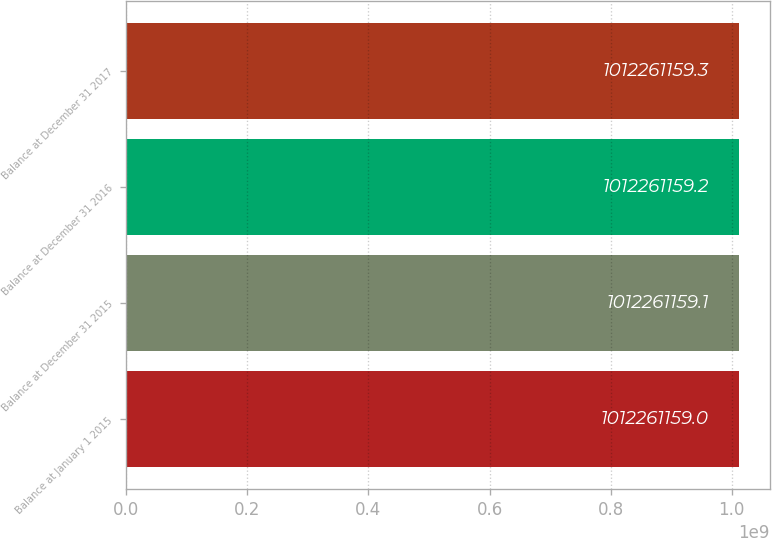<chart> <loc_0><loc_0><loc_500><loc_500><bar_chart><fcel>Balance at January 1 2015<fcel>Balance at December 31 2015<fcel>Balance at December 31 2016<fcel>Balance at December 31 2017<nl><fcel>1.01226e+09<fcel>1.01226e+09<fcel>1.01226e+09<fcel>1.01226e+09<nl></chart> 